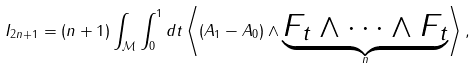Convert formula to latex. <formula><loc_0><loc_0><loc_500><loc_500>I _ { 2 n + 1 } = ( n + 1 ) \int _ { \mathcal { M } } \int ^ { 1 } _ { 0 } d t \left \langle ( A _ { 1 } - A _ { 0 } ) \wedge \underbrace { F _ { t } \wedge \dots \wedge F _ { t } } _ { n } \right \rangle ,</formula> 